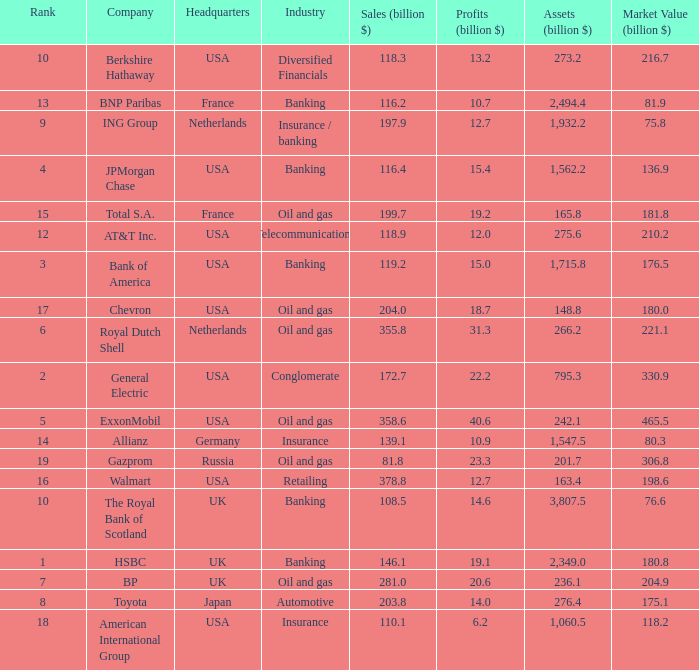What industry features a corporation with an 80.3 billion market valuation? Insurance. 